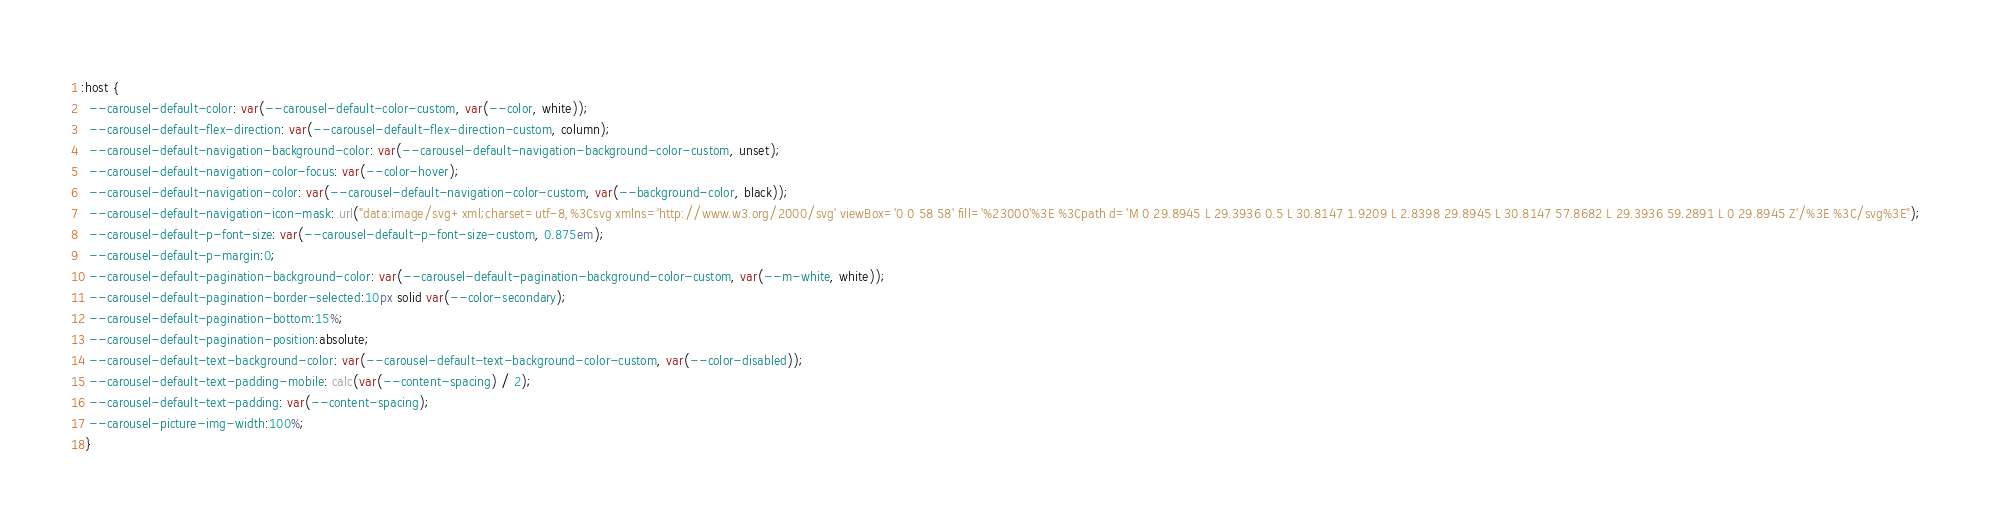<code> <loc_0><loc_0><loc_500><loc_500><_CSS_>:host {
  --carousel-default-color: var(--carousel-default-color-custom, var(--color, white));
  --carousel-default-flex-direction: var(--carousel-default-flex-direction-custom, column);
  --carousel-default-navigation-background-color: var(--carousel-default-navigation-background-color-custom, unset);
  --carousel-default-navigation-color-focus: var(--color-hover);
  --carousel-default-navigation-color: var(--carousel-default-navigation-color-custom, var(--background-color, black));
  --carousel-default-navigation-icon-mask: url("data:image/svg+xml;charset=utf-8,%3Csvg xmlns='http://www.w3.org/2000/svg' viewBox='0 0 58 58' fill='%23000'%3E %3Cpath d='M 0 29.8945 L 29.3936 0.5 L 30.8147 1.9209 L 2.8398 29.8945 L 30.8147 57.8682 L 29.3936 59.2891 L 0 29.8945 Z'/%3E %3C/svg%3E");
  --carousel-default-p-font-size: var(--carousel-default-p-font-size-custom, 0.875em);
  --carousel-default-p-margin:0;
  --carousel-default-pagination-background-color: var(--carousel-default-pagination-background-color-custom, var(--m-white, white));
  --carousel-default-pagination-border-selected:10px solid var(--color-secondary);
  --carousel-default-pagination-bottom:15%;
  --carousel-default-pagination-position:absolute;
  --carousel-default-text-background-color: var(--carousel-default-text-background-color-custom, var(--color-disabled));
  --carousel-default-text-padding-mobile: calc(var(--content-spacing) / 2);
  --carousel-default-text-padding: var(--content-spacing);
  --carousel-picture-img-width:100%;
 }</code> 